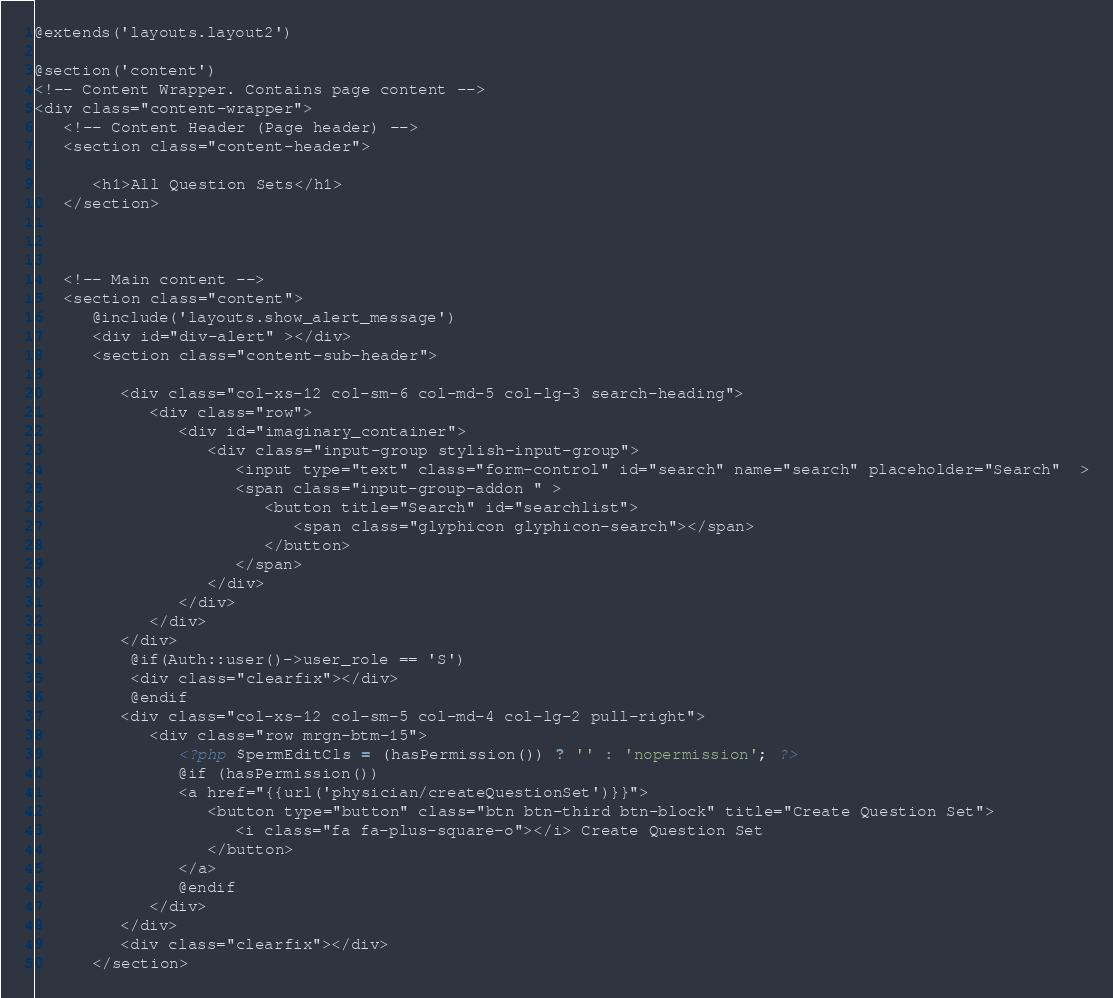Convert code to text. <code><loc_0><loc_0><loc_500><loc_500><_PHP_>@extends('layouts.layout2')

@section('content')
<!-- Content Wrapper. Contains page content -->
<div class="content-wrapper">
   <!-- Content Header (Page header) -->
   <section class="content-header">

      <h1>All Question Sets</h1>
   </section>



   <!-- Main content -->
   <section class="content">
      @include('layouts.show_alert_message')
      <div id="div-alert" ></div>
      <section class="content-sub-header">

         <div class="col-xs-12 col-sm-6 col-md-5 col-lg-3 search-heading">
            <div class="row">
               <div id="imaginary_container">
                  <div class="input-group stylish-input-group">
                     <input type="text" class="form-control" id="search" name="search" placeholder="Search"  >
                     <span class="input-group-addon " >
                        <button title="Search" id="searchlist">
                           <span class="glyphicon glyphicon-search"></span>
                        </button>
                     </span>
                  </div>
               </div>
            </div>
         </div>   
          @if(Auth::user()->user_role == 'S')
          <div class="clearfix"></div>
          @endif
         <div class="col-xs-12 col-sm-5 col-md-4 col-lg-2 pull-right">
            <div class="row mrgn-btm-15">               
               <?php $permEditCls = (hasPermission()) ? '' : 'nopermission'; ?>
               @if (hasPermission())
               <a href="{{url('physician/createQuestionSet')}}">
                  <button type="button" class="btn btn-third btn-block" title="Create Question Set">
                     <i class="fa fa-plus-square-o"></i> Create Question Set
                  </button>
               </a>
               @endif
            </div>
         </div>
         <div class="clearfix"></div>
      </section></code> 